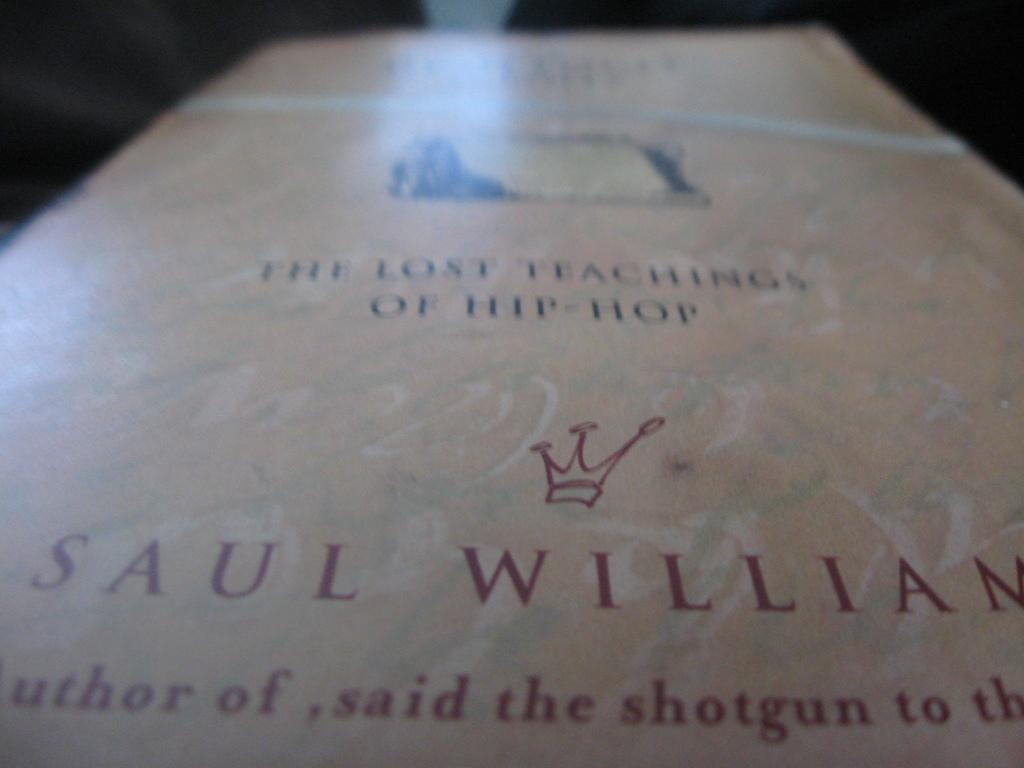Provide a one-sentence caption for the provided image. A PAGE IN A BOOK WITH THE AUTHOR Sul william called first teachings of hip hop. 